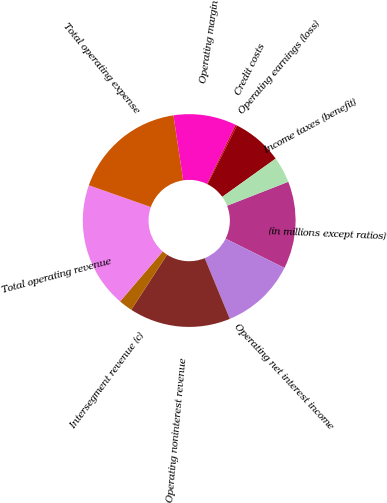<chart> <loc_0><loc_0><loc_500><loc_500><pie_chart><fcel>(in millions except ratios)<fcel>Operating net interest income<fcel>Operating noninterest revenue<fcel>Intersegment revenue (c)<fcel>Total operating revenue<fcel>Total operating expense<fcel>Operating margin<fcel>Credit costs<fcel>Operating earnings (loss)<fcel>Income taxes (benefit)<nl><fcel>13.28%<fcel>11.42%<fcel>15.4%<fcel>2.09%<fcel>19.13%<fcel>17.26%<fcel>9.55%<fcel>0.23%<fcel>7.69%<fcel>3.96%<nl></chart> 